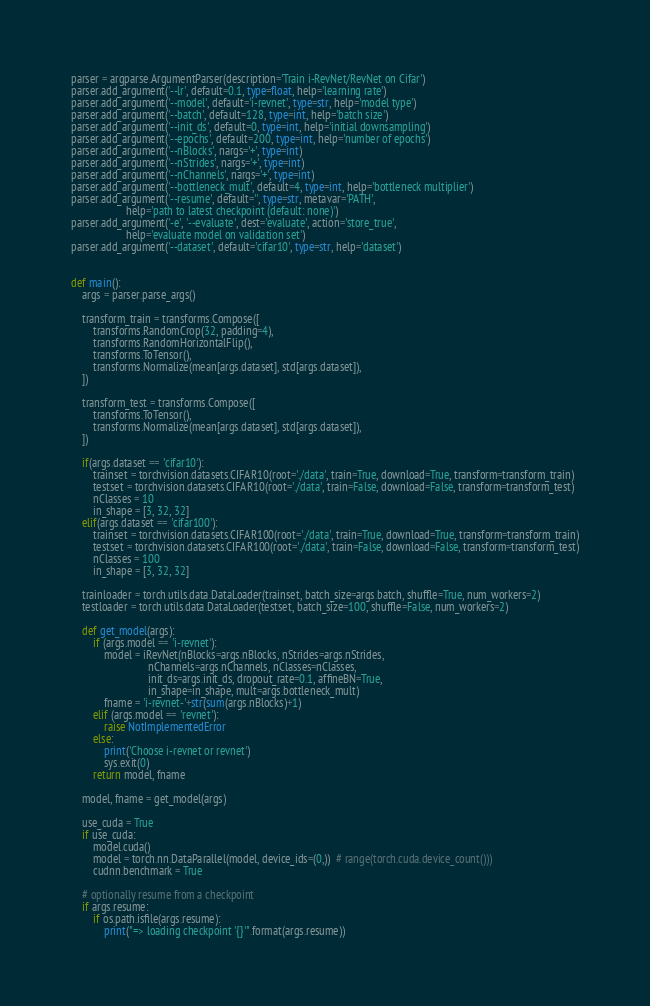Convert code to text. <code><loc_0><loc_0><loc_500><loc_500><_Python_>parser = argparse.ArgumentParser(description='Train i-RevNet/RevNet on Cifar')
parser.add_argument('--lr', default=0.1, type=float, help='learning rate')
parser.add_argument('--model', default='i-revnet', type=str, help='model type')
parser.add_argument('--batch', default=128, type=int, help='batch size')
parser.add_argument('--init_ds', default=0, type=int, help='initial downsampling')
parser.add_argument('--epochs', default=200, type=int, help='number of epochs')
parser.add_argument('--nBlocks', nargs='+', type=int)
parser.add_argument('--nStrides', nargs='+', type=int)
parser.add_argument('--nChannels', nargs='+', type=int)
parser.add_argument('--bottleneck_mult', default=4, type=int, help='bottleneck multiplier')
parser.add_argument('--resume', default='', type=str, metavar='PATH',
                    help='path to latest checkpoint (default: none)')
parser.add_argument('-e', '--evaluate', dest='evaluate', action='store_true',
                    help='evaluate model on validation set')
parser.add_argument('--dataset', default='cifar10', type=str, help='dataset')


def main():
    args = parser.parse_args()

    transform_train = transforms.Compose([
        transforms.RandomCrop(32, padding=4),
        transforms.RandomHorizontalFlip(),
        transforms.ToTensor(),
        transforms.Normalize(mean[args.dataset], std[args.dataset]),
    ])

    transform_test = transforms.Compose([
        transforms.ToTensor(),
        transforms.Normalize(mean[args.dataset], std[args.dataset]),
    ])

    if(args.dataset == 'cifar10'):
        trainset = torchvision.datasets.CIFAR10(root='./data', train=True, download=True, transform=transform_train)
        testset = torchvision.datasets.CIFAR10(root='./data', train=False, download=False, transform=transform_test)
        nClasses = 10
        in_shape = [3, 32, 32]
    elif(args.dataset == 'cifar100'):
        trainset = torchvision.datasets.CIFAR100(root='./data', train=True, download=True, transform=transform_train)
        testset = torchvision.datasets.CIFAR100(root='./data', train=False, download=False, transform=transform_test)
        nClasses = 100
        in_shape = [3, 32, 32]

    trainloader = torch.utils.data.DataLoader(trainset, batch_size=args.batch, shuffle=True, num_workers=2)
    testloader = torch.utils.data.DataLoader(testset, batch_size=100, shuffle=False, num_workers=2)

    def get_model(args):
        if (args.model == 'i-revnet'):
            model = iRevNet(nBlocks=args.nBlocks, nStrides=args.nStrides,
                            nChannels=args.nChannels, nClasses=nClasses,
                            init_ds=args.init_ds, dropout_rate=0.1, affineBN=True,
                            in_shape=in_shape, mult=args.bottleneck_mult)
            fname = 'i-revnet-'+str(sum(args.nBlocks)+1)
        elif (args.model == 'revnet'):
            raise NotImplementedError
        else:
            print('Choose i-revnet or revnet')
            sys.exit(0)
        return model, fname

    model, fname = get_model(args)

    use_cuda = True
    if use_cuda:
        model.cuda()
        model = torch.nn.DataParallel(model, device_ids=(0,))  # range(torch.cuda.device_count()))
        cudnn.benchmark = True

    # optionally resume from a checkpoint
    if args.resume:
        if os.path.isfile(args.resume):
            print("=> loading checkpoint '{}'".format(args.resume))</code> 